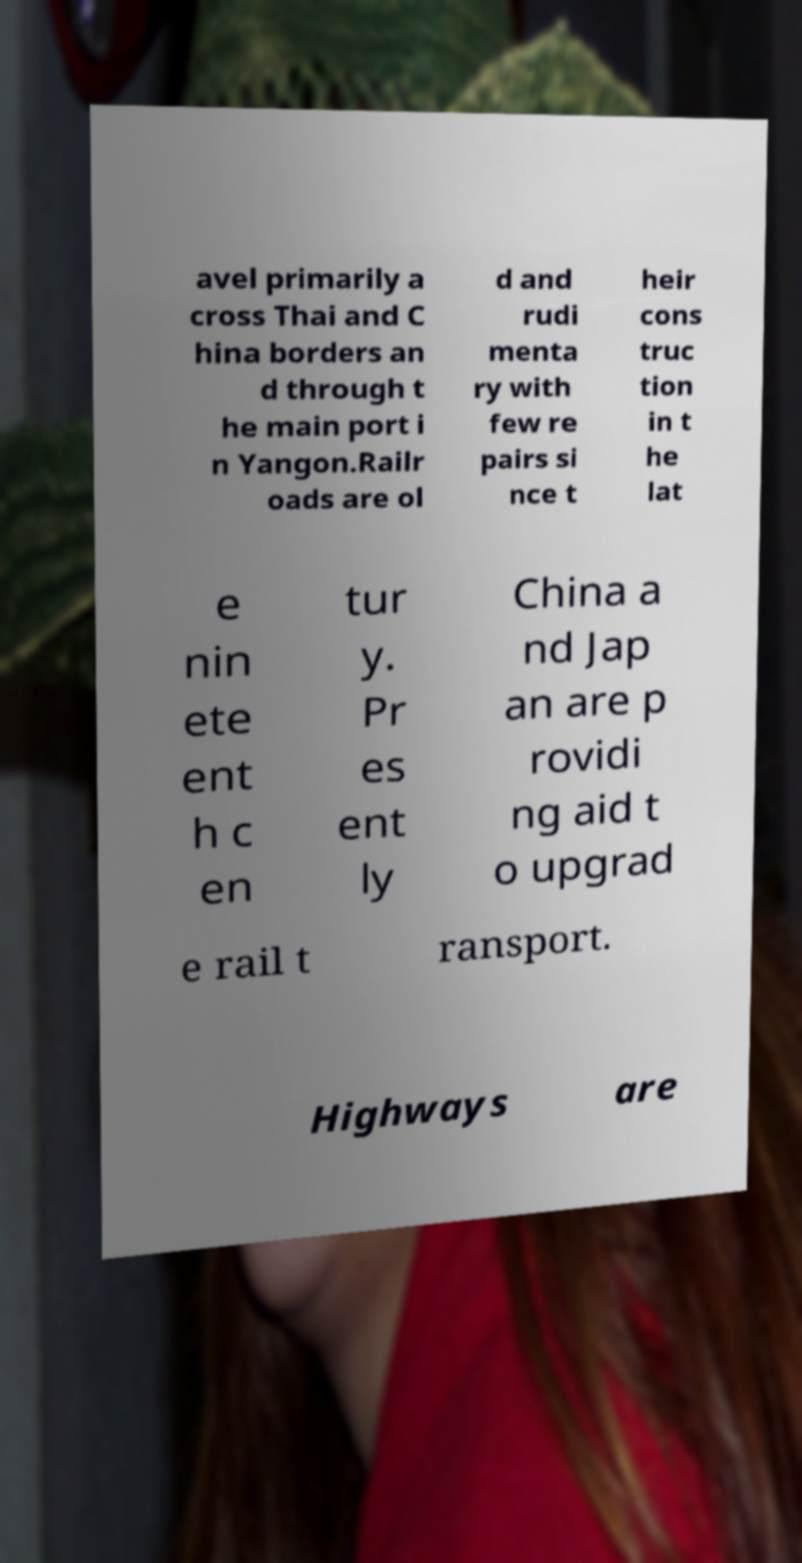I need the written content from this picture converted into text. Can you do that? avel primarily a cross Thai and C hina borders an d through t he main port i n Yangon.Railr oads are ol d and rudi menta ry with few re pairs si nce t heir cons truc tion in t he lat e nin ete ent h c en tur y. Pr es ent ly China a nd Jap an are p rovidi ng aid t o upgrad e rail t ransport. Highways are 